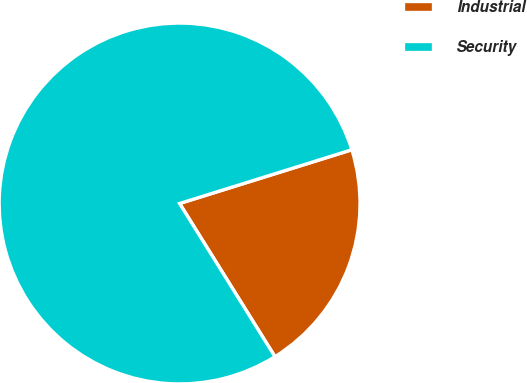Convert chart to OTSL. <chart><loc_0><loc_0><loc_500><loc_500><pie_chart><fcel>Industrial<fcel>Security<nl><fcel>20.95%<fcel>79.05%<nl></chart> 